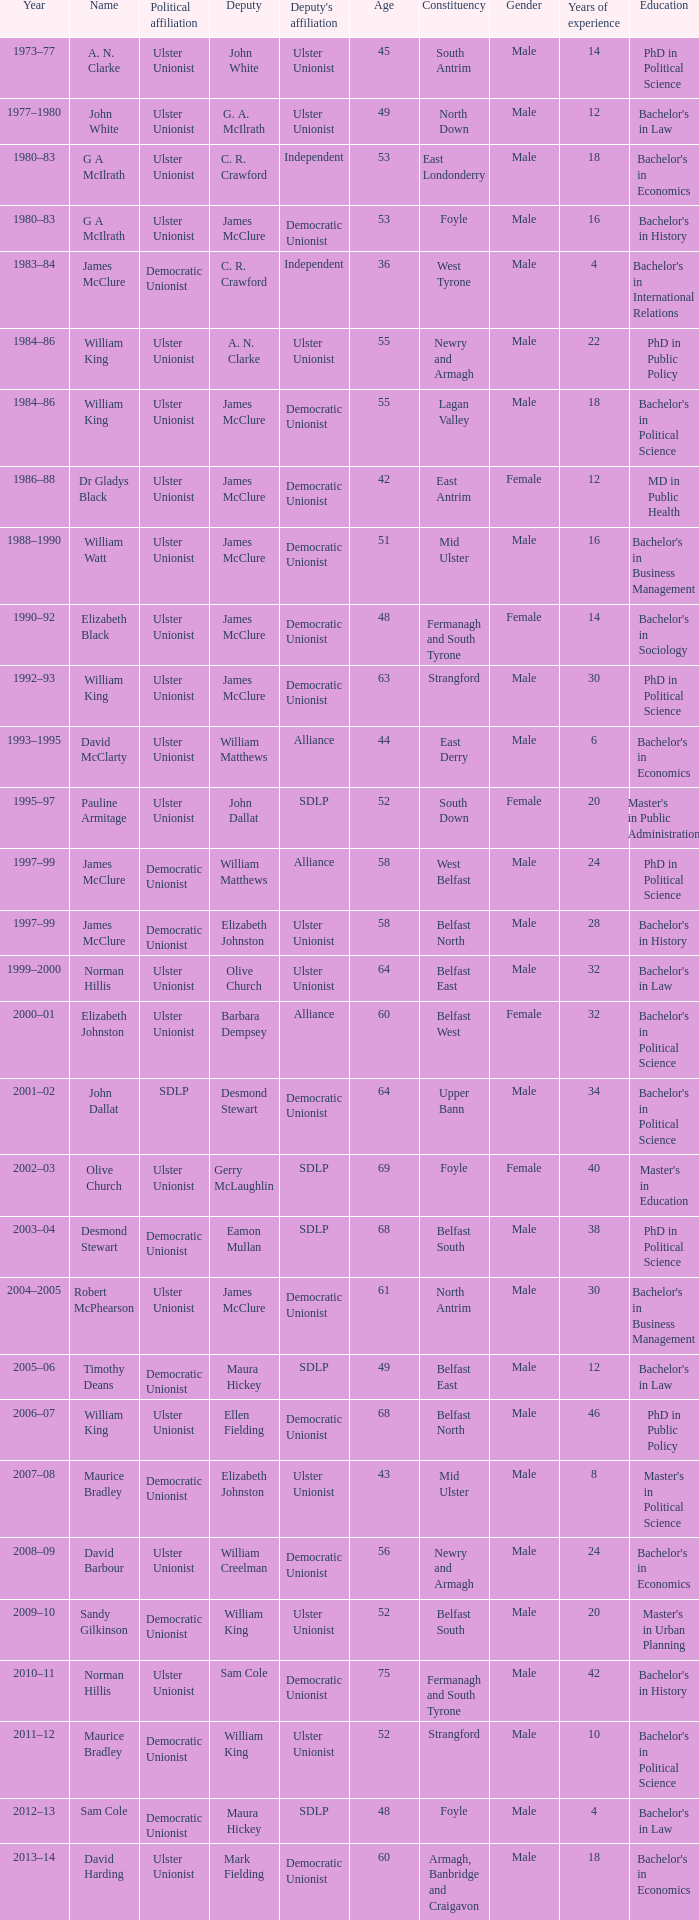I'm looking to parse the entire table for insights. Could you assist me with that? {'header': ['Year', 'Name', 'Political affiliation', 'Deputy', "Deputy's affiliation", 'Age', 'Constituency', 'Gender', 'Years of experience', 'Education'], 'rows': [['1973–77', 'A. N. Clarke', 'Ulster Unionist', 'John White', 'Ulster Unionist', '45', 'South Antrim', 'Male', '14', 'PhD in Political Science'], ['1977–1980', 'John White', 'Ulster Unionist', 'G. A. McIlrath', 'Ulster Unionist', '49', 'North Down', 'Male', '12', "Bachelor's in Law"], ['1980–83', 'G A McIlrath', 'Ulster Unionist', 'C. R. Crawford', 'Independent', '53', 'East Londonderry', 'Male', '18', "Bachelor's in Economics"], ['1980–83', 'G A McIlrath', 'Ulster Unionist', 'James McClure', 'Democratic Unionist', '53', 'Foyle', 'Male', '16', "Bachelor's in History"], ['1983–84', 'James McClure', 'Democratic Unionist', 'C. R. Crawford', 'Independent', '36', 'West Tyrone', 'Male', '4', "Bachelor's in International Relations"], ['1984–86', 'William King', 'Ulster Unionist', 'A. N. Clarke', 'Ulster Unionist', '55', 'Newry and Armagh', 'Male', '22', 'PhD in Public Policy'], ['1984–86', 'William King', 'Ulster Unionist', 'James McClure', 'Democratic Unionist', '55', 'Lagan Valley', 'Male', '18', "Bachelor's in Political Science"], ['1986–88', 'Dr Gladys Black', 'Ulster Unionist', 'James McClure', 'Democratic Unionist', '42', 'East Antrim', 'Female', '12', 'MD in Public Health'], ['1988–1990', 'William Watt', 'Ulster Unionist', 'James McClure', 'Democratic Unionist', '51', 'Mid Ulster', 'Male', '16', "Bachelor's in Business Management"], ['1990–92', 'Elizabeth Black', 'Ulster Unionist', 'James McClure', 'Democratic Unionist', '48', 'Fermanagh and South Tyrone', 'Female', '14', "Bachelor's in Sociology"], ['1992–93', 'William King', 'Ulster Unionist', 'James McClure', 'Democratic Unionist', '63', 'Strangford', 'Male', '30', 'PhD in Political Science'], ['1993–1995', 'David McClarty', 'Ulster Unionist', 'William Matthews', 'Alliance', '44', 'East Derry', 'Male', '6', "Bachelor's in Economics"], ['1995–97', 'Pauline Armitage', 'Ulster Unionist', 'John Dallat', 'SDLP', '52', 'South Down', 'Female', '20', "Master's in Public Administration"], ['1997–99', 'James McClure', 'Democratic Unionist', 'William Matthews', 'Alliance', '58', 'West Belfast', 'Male', '24', 'PhD in Political Science'], ['1997–99', 'James McClure', 'Democratic Unionist', 'Elizabeth Johnston', 'Ulster Unionist', '58', 'Belfast North', 'Male', '28', "Bachelor's in History"], ['1999–2000', 'Norman Hillis', 'Ulster Unionist', 'Olive Church', 'Ulster Unionist', '64', 'Belfast East', 'Male', '32', "Bachelor's in Law"], ['2000–01', 'Elizabeth Johnston', 'Ulster Unionist', 'Barbara Dempsey', 'Alliance', '60', 'Belfast West', 'Female', '32', "Bachelor's in Political Science"], ['2001–02', 'John Dallat', 'SDLP', 'Desmond Stewart', 'Democratic Unionist', '64', 'Upper Bann', 'Male', '34', "Bachelor's in Political Science"], ['2002–03', 'Olive Church', 'Ulster Unionist', 'Gerry McLaughlin', 'SDLP', '69', 'Foyle', 'Female', '40', "Master's in Education"], ['2003–04', 'Desmond Stewart', 'Democratic Unionist', 'Eamon Mullan', 'SDLP', '68', 'Belfast South', 'Male', '38', 'PhD in Political Science'], ['2004–2005', 'Robert McPhearson', 'Ulster Unionist', 'James McClure', 'Democratic Unionist', '61', 'North Antrim', 'Male', '30', "Bachelor's in Business Management"], ['2005–06', 'Timothy Deans', 'Democratic Unionist', 'Maura Hickey', 'SDLP', '49', 'Belfast East', 'Male', '12', "Bachelor's in Law"], ['2006–07', 'William King', 'Ulster Unionist', 'Ellen Fielding', 'Democratic Unionist', '68', 'Belfast North', 'Male', '46', 'PhD in Public Policy'], ['2007–08', 'Maurice Bradley', 'Democratic Unionist', 'Elizabeth Johnston', 'Ulster Unionist', '43', 'Mid Ulster', 'Male', '8', "Master's in Political Science"], ['2008–09', 'David Barbour', 'Ulster Unionist', 'William Creelman', 'Democratic Unionist', '56', 'Newry and Armagh', 'Male', '24', "Bachelor's in Economics"], ['2009–10', 'Sandy Gilkinson', 'Democratic Unionist', 'William King', 'Ulster Unionist', '52', 'Belfast South', 'Male', '20', "Master's in Urban Planning"], ['2010–11', 'Norman Hillis', 'Ulster Unionist', 'Sam Cole', 'Democratic Unionist', '75', 'Fermanagh and South Tyrone', 'Male', '42', "Bachelor's in History"], ['2011–12', 'Maurice Bradley', 'Democratic Unionist', 'William King', 'Ulster Unionist', '52', 'Strangford', 'Male', '10', "Bachelor's in Political Science"], ['2012–13', 'Sam Cole', 'Democratic Unionist', 'Maura Hickey', 'SDLP', '48', 'Foyle', 'Male', '4', "Bachelor's in Law"], ['2013–14', 'David Harding', 'Ulster Unionist', 'Mark Fielding', 'Democratic Unionist', '60', 'Armagh, Banbridge and Craigavon', 'Male', '18', "Bachelor's in Economics"]]} What is the name of the deputy in 1992–93? James McClure. 